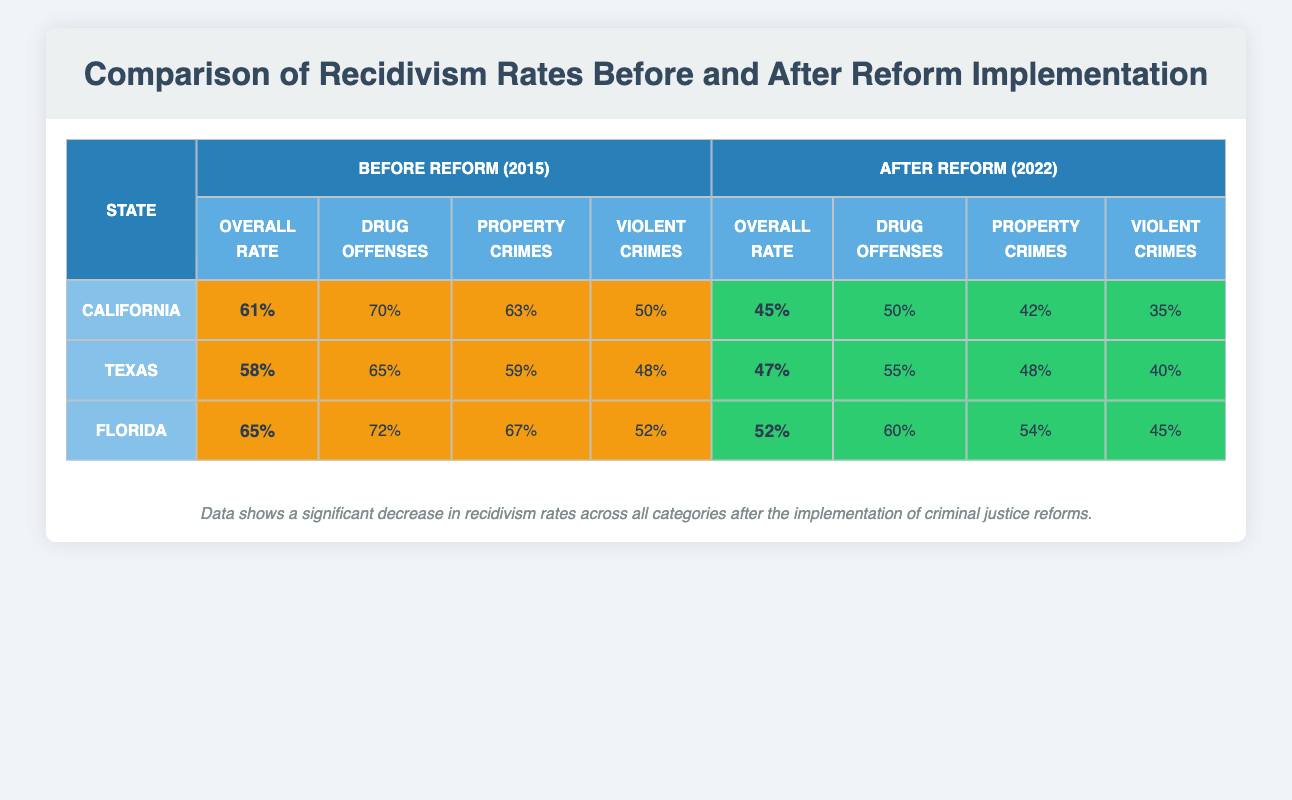What is the overall recidivism rate for California before the reform? The table shows that the overall recidivism rate for California before the reform in 2015 is listed as 61%.
Answer: 61% What was the rate for violent crimes in Texas after the reform? According to the table, the rate for violent crimes in Texas after the reform in 2022 is 40%.
Answer: 40% Which state had the highest overall recidivism rate before the reform? By comparing the overall rates, California at 61% had the highest rate among the three states (California, Texas, Florida) before the reform. Texas had 58% and Florida had 65%, which means Texas had the lowest overall rate.
Answer: False What is the difference in the overall recidivism rates for Florida before and after the reform? The overall rate for Florida before the reform was 65% and after the reform it was 52%. Calculating the difference: 65% - 52% = 13%.
Answer: 13% Which state's drug offenses had the greatest reduction in recidivism rates after the reform? Looking at the drug offenses for California, Texas, and Florida, California's rate went from 70% to 50%, showing a reduction of 20%. Texas decreased by 10%, and Florida decreased by 12%. Thus, California had the greatest reduction.
Answer: California What is the average overall recidivism rate before the reform for all three states? To find the average, we sum the overall rates: 61% (California) + 58% (Texas) + 65% (Florida) = 184%. Then, divide by 3 (the number of states): 184% / 3 = 61.33%. Rounding gives an average overall rate of approximately 61%.
Answer: 61% Did property crime recidivism rates increase in any state after the reform? Comparing the data, California's property crime rate went from 63% to 42% (a decrease), Texas went from 59% to 48% (a decrease), and Florida from 67% to 54% (also a decrease). Therefore, there is no increase in property crime rates for any state after the reform.
Answer: No What is the lowest recidivism rate for drug offenses after the reform? The table indicates the rates for drug offenses after the reform as follows: California 50%, Texas 55%, and Florida 60%. The lowest among these is California at 50%.
Answer: 50% Which state had the lowest reduction in overall recidivism rate after the reform? Looking at the overall rates: California decreased from 61% to 45% (16%), Texas decreased from 58% to 47% (11%), and Florida decreased from 65% to 52% (13%). Texas has the lowest reduction of 11%.
Answer: Texas 